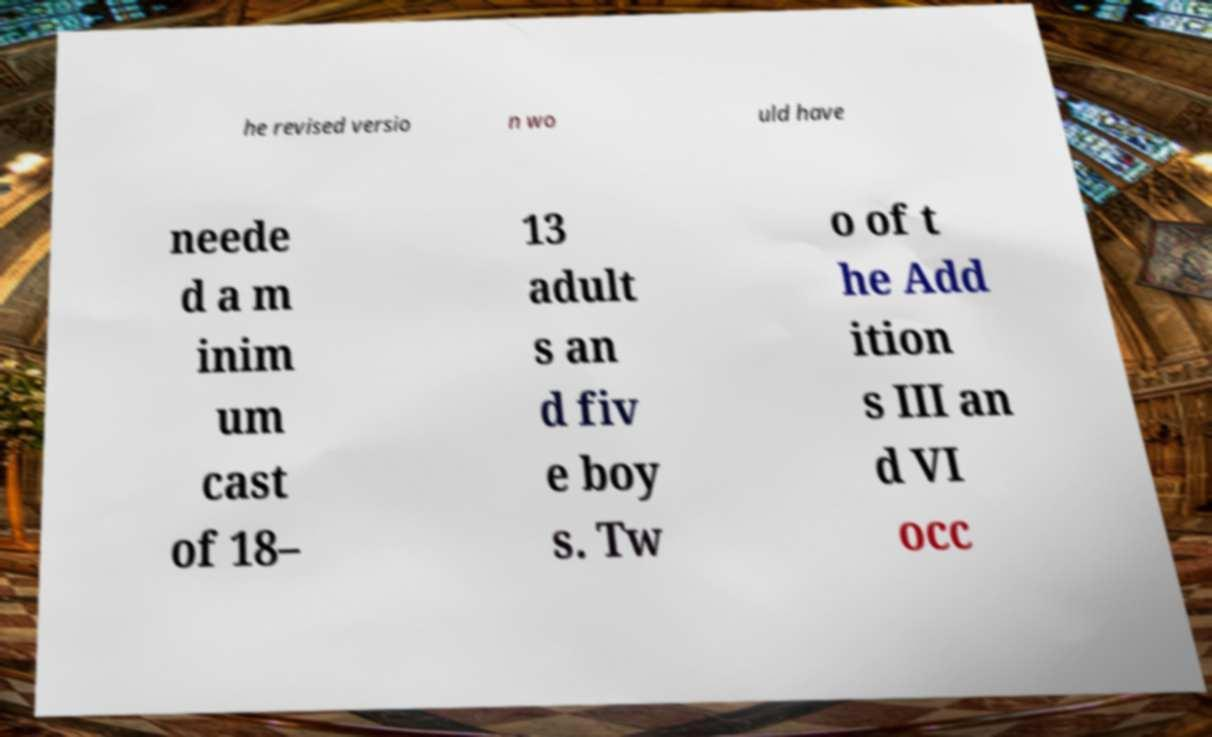What messages or text are displayed in this image? I need them in a readable, typed format. he revised versio n wo uld have neede d a m inim um cast of 18– 13 adult s an d fiv e boy s. Tw o of t he Add ition s III an d VI occ 